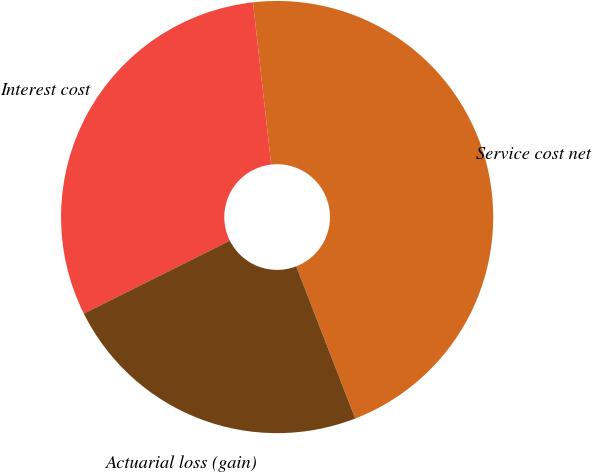Convert chart. <chart><loc_0><loc_0><loc_500><loc_500><pie_chart><fcel>Service cost net<fcel>Interest cost<fcel>Actuarial loss (gain)<nl><fcel>45.89%<fcel>30.59%<fcel>23.51%<nl></chart> 